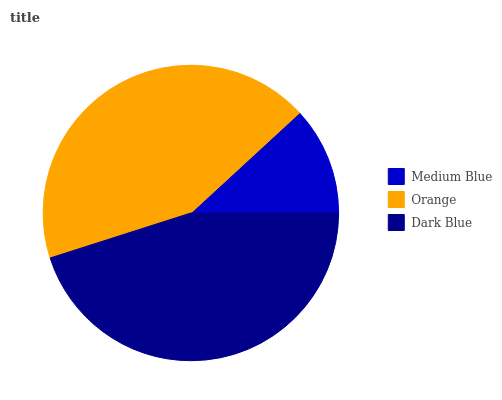Is Medium Blue the minimum?
Answer yes or no. Yes. Is Dark Blue the maximum?
Answer yes or no. Yes. Is Orange the minimum?
Answer yes or no. No. Is Orange the maximum?
Answer yes or no. No. Is Orange greater than Medium Blue?
Answer yes or no. Yes. Is Medium Blue less than Orange?
Answer yes or no. Yes. Is Medium Blue greater than Orange?
Answer yes or no. No. Is Orange less than Medium Blue?
Answer yes or no. No. Is Orange the high median?
Answer yes or no. Yes. Is Orange the low median?
Answer yes or no. Yes. Is Dark Blue the high median?
Answer yes or no. No. Is Medium Blue the low median?
Answer yes or no. No. 